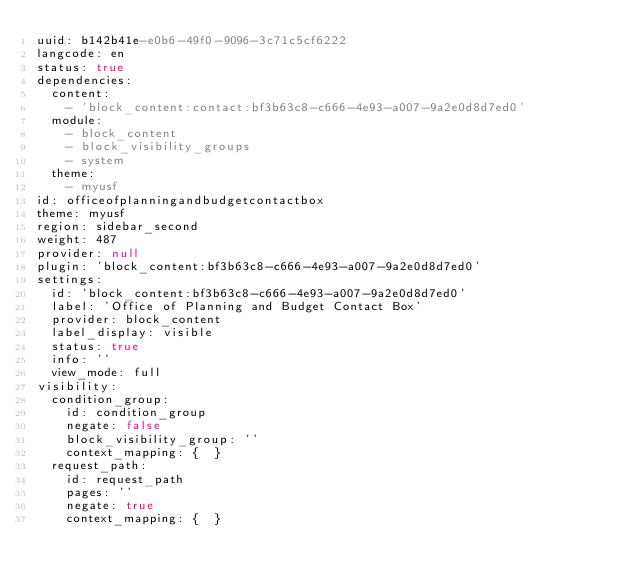Convert code to text. <code><loc_0><loc_0><loc_500><loc_500><_YAML_>uuid: b142b41e-e0b6-49f0-9096-3c71c5cf6222
langcode: en
status: true
dependencies:
  content:
    - 'block_content:contact:bf3b63c8-c666-4e93-a007-9a2e0d8d7ed0'
  module:
    - block_content
    - block_visibility_groups
    - system
  theme:
    - myusf
id: officeofplanningandbudgetcontactbox
theme: myusf
region: sidebar_second
weight: 487
provider: null
plugin: 'block_content:bf3b63c8-c666-4e93-a007-9a2e0d8d7ed0'
settings:
  id: 'block_content:bf3b63c8-c666-4e93-a007-9a2e0d8d7ed0'
  label: 'Office of Planning and Budget Contact Box'
  provider: block_content
  label_display: visible
  status: true
  info: ''
  view_mode: full
visibility:
  condition_group:
    id: condition_group
    negate: false
    block_visibility_group: ''
    context_mapping: {  }
  request_path:
    id: request_path
    pages: ''
    negate: true
    context_mapping: {  }
</code> 